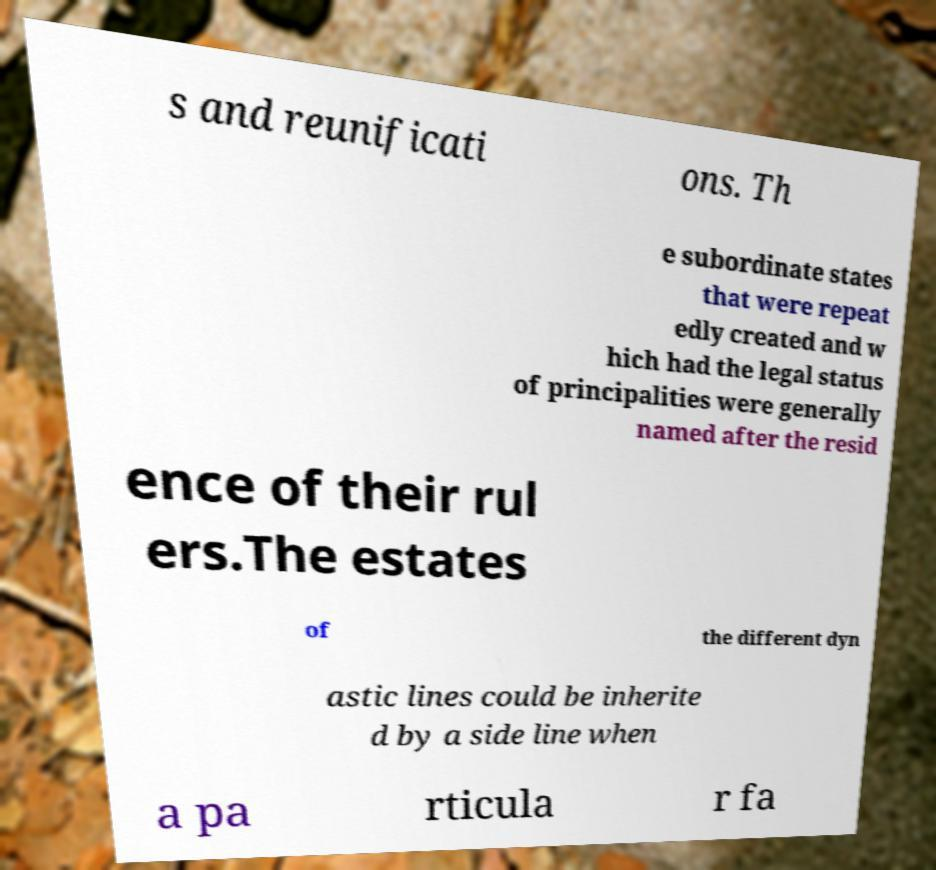Can you read and provide the text displayed in the image?This photo seems to have some interesting text. Can you extract and type it out for me? s and reunificati ons. Th e subordinate states that were repeat edly created and w hich had the legal status of principalities were generally named after the resid ence of their rul ers.The estates of the different dyn astic lines could be inherite d by a side line when a pa rticula r fa 